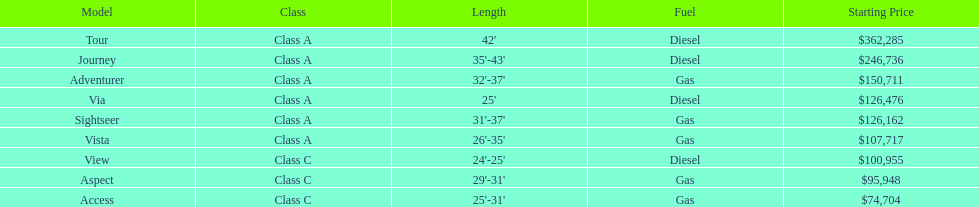What is the title of the highest-priced winnebago model? Tour. 